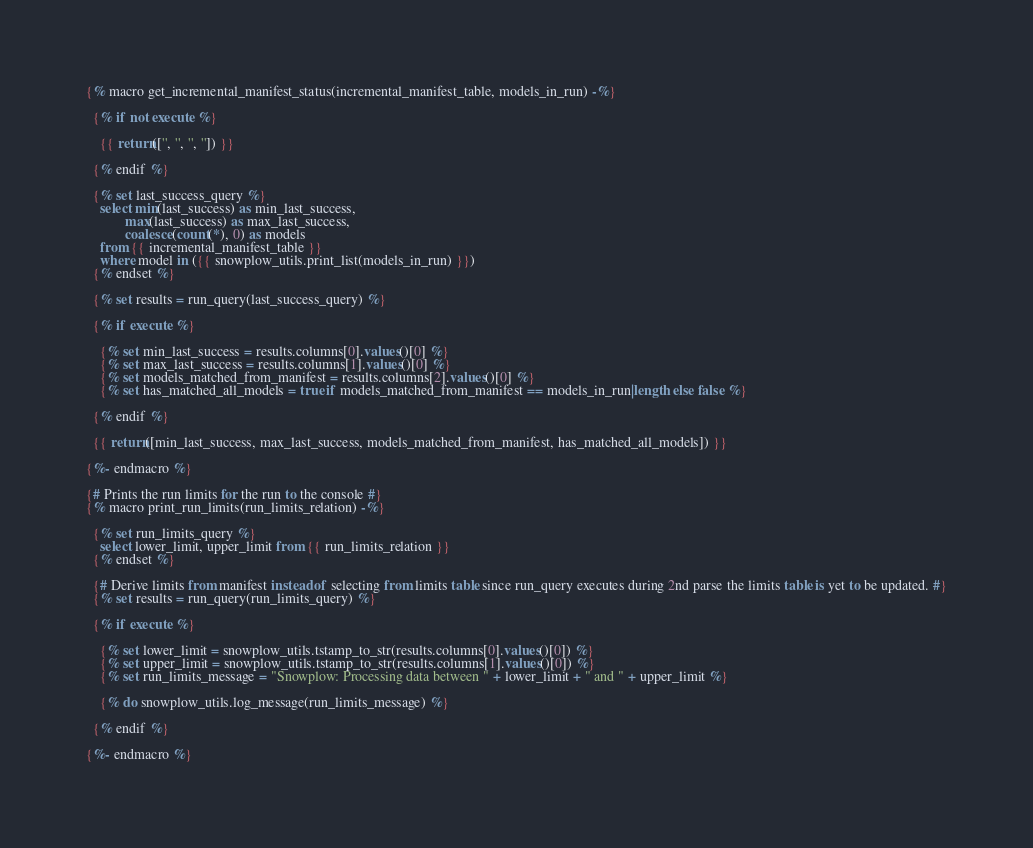<code> <loc_0><loc_0><loc_500><loc_500><_SQL_>{% macro get_incremental_manifest_status(incremental_manifest_table, models_in_run) -%}

  {% if not execute %}

    {{ return(['', '', '', '']) }}

  {% endif %}

  {% set last_success_query %}
    select min(last_success) as min_last_success,
           max(last_success) as max_last_success,
           coalesce(count(*), 0) as models
    from {{ incremental_manifest_table }}
    where model in ({{ snowplow_utils.print_list(models_in_run) }})
  {% endset %}

  {% set results = run_query(last_success_query) %}

  {% if execute %}

    {% set min_last_success = results.columns[0].values()[0] %}
    {% set max_last_success = results.columns[1].values()[0] %}
    {% set models_matched_from_manifest = results.columns[2].values()[0] %}
    {% set has_matched_all_models = true if models_matched_from_manifest == models_in_run|length else false %}

  {% endif %}

  {{ return([min_last_success, max_last_success, models_matched_from_manifest, has_matched_all_models]) }}

{%- endmacro %}

{# Prints the run limits for the run to the console #}
{% macro print_run_limits(run_limits_relation) -%}

  {% set run_limits_query %}
    select lower_limit, upper_limit from {{ run_limits_relation }}
  {% endset %}

  {# Derive limits from manifest instead of selecting from limits table since run_query executes during 2nd parse the limits table is yet to be updated. #}
  {% set results = run_query(run_limits_query) %}

  {% if execute %}

    {% set lower_limit = snowplow_utils.tstamp_to_str(results.columns[0].values()[0]) %}
    {% set upper_limit = snowplow_utils.tstamp_to_str(results.columns[1].values()[0]) %}
    {% set run_limits_message = "Snowplow: Processing data between " + lower_limit + " and " + upper_limit %}

    {% do snowplow_utils.log_message(run_limits_message) %}

  {% endif %}

{%- endmacro %}
</code> 